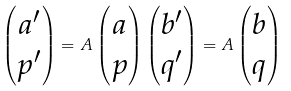Convert formula to latex. <formula><loc_0><loc_0><loc_500><loc_500>\begin{pmatrix} a ^ { \prime } \\ p ^ { \prime } \end{pmatrix} = A \begin{pmatrix} a \\ p \end{pmatrix} \begin{pmatrix} b ^ { \prime } \\ q ^ { \prime } \end{pmatrix} = A \begin{pmatrix} b \\ q \end{pmatrix}</formula> 